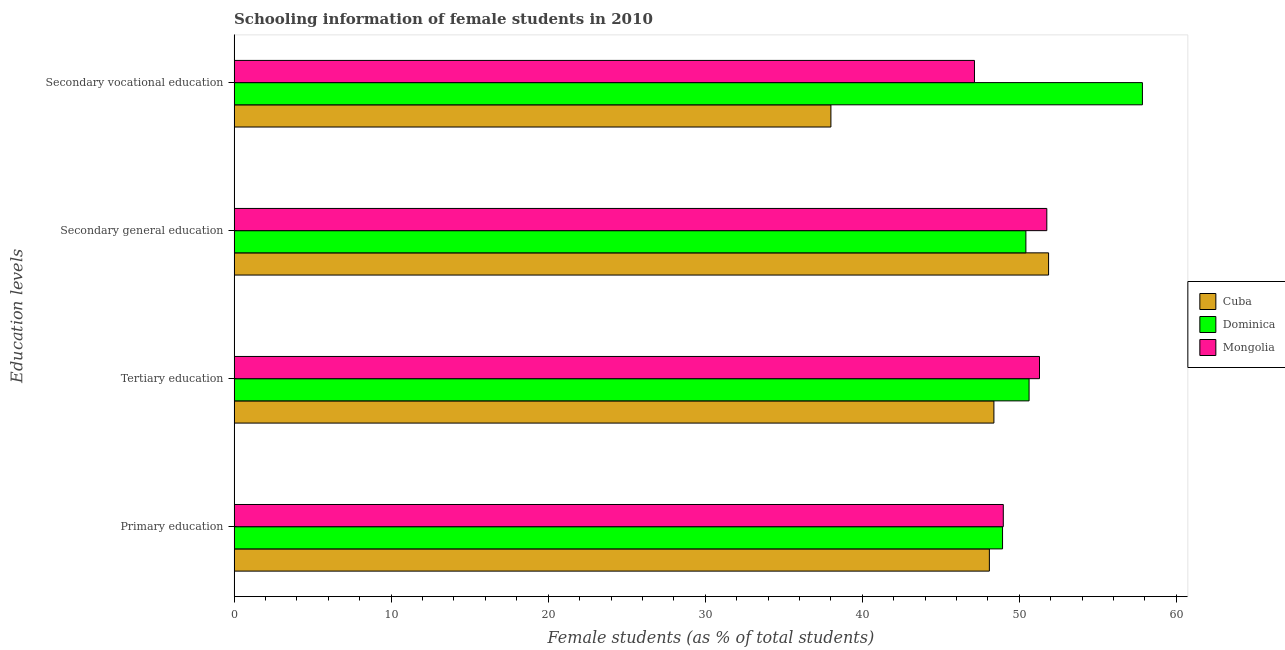Are the number of bars per tick equal to the number of legend labels?
Offer a very short reply. Yes. Are the number of bars on each tick of the Y-axis equal?
Make the answer very short. Yes. How many bars are there on the 4th tick from the bottom?
Offer a very short reply. 3. What is the label of the 3rd group of bars from the top?
Provide a succinct answer. Tertiary education. What is the percentage of female students in secondary vocational education in Mongolia?
Offer a terse response. 47.14. Across all countries, what is the maximum percentage of female students in secondary education?
Keep it short and to the point. 51.86. Across all countries, what is the minimum percentage of female students in secondary education?
Your answer should be compact. 50.42. In which country was the percentage of female students in tertiary education maximum?
Ensure brevity in your answer.  Mongolia. In which country was the percentage of female students in secondary vocational education minimum?
Provide a short and direct response. Cuba. What is the total percentage of female students in secondary vocational education in the graph?
Your answer should be compact. 142.98. What is the difference between the percentage of female students in secondary vocational education in Mongolia and that in Cuba?
Your response must be concise. 9.14. What is the difference between the percentage of female students in secondary vocational education in Mongolia and the percentage of female students in tertiary education in Cuba?
Make the answer very short. -1.24. What is the average percentage of female students in secondary education per country?
Provide a short and direct response. 51.34. What is the difference between the percentage of female students in secondary education and percentage of female students in secondary vocational education in Mongolia?
Make the answer very short. 4.61. What is the ratio of the percentage of female students in primary education in Dominica to that in Cuba?
Your answer should be compact. 1.02. What is the difference between the highest and the second highest percentage of female students in primary education?
Your answer should be very brief. 0.05. What is the difference between the highest and the lowest percentage of female students in secondary vocational education?
Offer a terse response. 19.84. In how many countries, is the percentage of female students in primary education greater than the average percentage of female students in primary education taken over all countries?
Keep it short and to the point. 2. Is it the case that in every country, the sum of the percentage of female students in tertiary education and percentage of female students in primary education is greater than the sum of percentage of female students in secondary vocational education and percentage of female students in secondary education?
Provide a succinct answer. No. What does the 1st bar from the top in Secondary general education represents?
Provide a succinct answer. Mongolia. What does the 2nd bar from the bottom in Secondary general education represents?
Your answer should be compact. Dominica. How many bars are there?
Provide a succinct answer. 12. Are all the bars in the graph horizontal?
Ensure brevity in your answer.  Yes. How many countries are there in the graph?
Make the answer very short. 3. Does the graph contain grids?
Your answer should be compact. No. Where does the legend appear in the graph?
Ensure brevity in your answer.  Center right. How are the legend labels stacked?
Make the answer very short. Vertical. What is the title of the graph?
Your answer should be compact. Schooling information of female students in 2010. What is the label or title of the X-axis?
Make the answer very short. Female students (as % of total students). What is the label or title of the Y-axis?
Keep it short and to the point. Education levels. What is the Female students (as % of total students) in Cuba in Primary education?
Provide a succinct answer. 48.09. What is the Female students (as % of total students) of Dominica in Primary education?
Provide a short and direct response. 48.93. What is the Female students (as % of total students) of Mongolia in Primary education?
Provide a short and direct response. 48.98. What is the Female students (as % of total students) in Cuba in Tertiary education?
Offer a very short reply. 48.38. What is the Female students (as % of total students) of Dominica in Tertiary education?
Make the answer very short. 50.62. What is the Female students (as % of total students) of Mongolia in Tertiary education?
Ensure brevity in your answer.  51.28. What is the Female students (as % of total students) of Cuba in Secondary general education?
Your response must be concise. 51.86. What is the Female students (as % of total students) of Dominica in Secondary general education?
Offer a very short reply. 50.42. What is the Female students (as % of total students) in Mongolia in Secondary general education?
Your answer should be compact. 51.75. What is the Female students (as % of total students) of Cuba in Secondary vocational education?
Keep it short and to the point. 38. What is the Female students (as % of total students) in Dominica in Secondary vocational education?
Your answer should be very brief. 57.84. What is the Female students (as % of total students) of Mongolia in Secondary vocational education?
Ensure brevity in your answer.  47.14. Across all Education levels, what is the maximum Female students (as % of total students) in Cuba?
Your answer should be very brief. 51.86. Across all Education levels, what is the maximum Female students (as % of total students) of Dominica?
Offer a very short reply. 57.84. Across all Education levels, what is the maximum Female students (as % of total students) in Mongolia?
Give a very brief answer. 51.75. Across all Education levels, what is the minimum Female students (as % of total students) in Cuba?
Make the answer very short. 38. Across all Education levels, what is the minimum Female students (as % of total students) of Dominica?
Make the answer very short. 48.93. Across all Education levels, what is the minimum Female students (as % of total students) of Mongolia?
Offer a very short reply. 47.14. What is the total Female students (as % of total students) in Cuba in the graph?
Your response must be concise. 186.34. What is the total Female students (as % of total students) in Dominica in the graph?
Make the answer very short. 207.81. What is the total Female students (as % of total students) of Mongolia in the graph?
Provide a short and direct response. 199.16. What is the difference between the Female students (as % of total students) of Cuba in Primary education and that in Tertiary education?
Keep it short and to the point. -0.29. What is the difference between the Female students (as % of total students) in Dominica in Primary education and that in Tertiary education?
Keep it short and to the point. -1.69. What is the difference between the Female students (as % of total students) in Mongolia in Primary education and that in Tertiary education?
Your response must be concise. -2.3. What is the difference between the Female students (as % of total students) of Cuba in Primary education and that in Secondary general education?
Your answer should be very brief. -3.77. What is the difference between the Female students (as % of total students) in Dominica in Primary education and that in Secondary general education?
Ensure brevity in your answer.  -1.49. What is the difference between the Female students (as % of total students) of Mongolia in Primary education and that in Secondary general education?
Your answer should be compact. -2.77. What is the difference between the Female students (as % of total students) in Cuba in Primary education and that in Secondary vocational education?
Ensure brevity in your answer.  10.09. What is the difference between the Female students (as % of total students) in Dominica in Primary education and that in Secondary vocational education?
Offer a very short reply. -8.91. What is the difference between the Female students (as % of total students) in Mongolia in Primary education and that in Secondary vocational education?
Offer a very short reply. 1.84. What is the difference between the Female students (as % of total students) in Cuba in Tertiary education and that in Secondary general education?
Provide a short and direct response. -3.48. What is the difference between the Female students (as % of total students) of Dominica in Tertiary education and that in Secondary general education?
Your response must be concise. 0.2. What is the difference between the Female students (as % of total students) of Mongolia in Tertiary education and that in Secondary general education?
Offer a terse response. -0.47. What is the difference between the Female students (as % of total students) of Cuba in Tertiary education and that in Secondary vocational education?
Provide a succinct answer. 10.38. What is the difference between the Female students (as % of total students) in Dominica in Tertiary education and that in Secondary vocational education?
Offer a very short reply. -7.22. What is the difference between the Female students (as % of total students) in Mongolia in Tertiary education and that in Secondary vocational education?
Offer a terse response. 4.14. What is the difference between the Female students (as % of total students) of Cuba in Secondary general education and that in Secondary vocational education?
Provide a short and direct response. 13.86. What is the difference between the Female students (as % of total students) in Dominica in Secondary general education and that in Secondary vocational education?
Give a very brief answer. -7.42. What is the difference between the Female students (as % of total students) of Mongolia in Secondary general education and that in Secondary vocational education?
Your response must be concise. 4.61. What is the difference between the Female students (as % of total students) of Cuba in Primary education and the Female students (as % of total students) of Dominica in Tertiary education?
Provide a short and direct response. -2.53. What is the difference between the Female students (as % of total students) of Cuba in Primary education and the Female students (as % of total students) of Mongolia in Tertiary education?
Your answer should be compact. -3.19. What is the difference between the Female students (as % of total students) in Dominica in Primary education and the Female students (as % of total students) in Mongolia in Tertiary education?
Provide a short and direct response. -2.35. What is the difference between the Female students (as % of total students) in Cuba in Primary education and the Female students (as % of total students) in Dominica in Secondary general education?
Provide a short and direct response. -2.33. What is the difference between the Female students (as % of total students) of Cuba in Primary education and the Female students (as % of total students) of Mongolia in Secondary general education?
Offer a very short reply. -3.66. What is the difference between the Female students (as % of total students) in Dominica in Primary education and the Female students (as % of total students) in Mongolia in Secondary general education?
Keep it short and to the point. -2.82. What is the difference between the Female students (as % of total students) in Cuba in Primary education and the Female students (as % of total students) in Dominica in Secondary vocational education?
Your answer should be very brief. -9.75. What is the difference between the Female students (as % of total students) of Cuba in Primary education and the Female students (as % of total students) of Mongolia in Secondary vocational education?
Offer a very short reply. 0.95. What is the difference between the Female students (as % of total students) in Dominica in Primary education and the Female students (as % of total students) in Mongolia in Secondary vocational education?
Keep it short and to the point. 1.79. What is the difference between the Female students (as % of total students) in Cuba in Tertiary education and the Female students (as % of total students) in Dominica in Secondary general education?
Ensure brevity in your answer.  -2.04. What is the difference between the Female students (as % of total students) of Cuba in Tertiary education and the Female students (as % of total students) of Mongolia in Secondary general education?
Provide a succinct answer. -3.37. What is the difference between the Female students (as % of total students) in Dominica in Tertiary education and the Female students (as % of total students) in Mongolia in Secondary general education?
Your response must be concise. -1.13. What is the difference between the Female students (as % of total students) in Cuba in Tertiary education and the Female students (as % of total students) in Dominica in Secondary vocational education?
Your answer should be very brief. -9.46. What is the difference between the Female students (as % of total students) in Cuba in Tertiary education and the Female students (as % of total students) in Mongolia in Secondary vocational education?
Offer a terse response. 1.24. What is the difference between the Female students (as % of total students) of Dominica in Tertiary education and the Female students (as % of total students) of Mongolia in Secondary vocational education?
Keep it short and to the point. 3.48. What is the difference between the Female students (as % of total students) of Cuba in Secondary general education and the Female students (as % of total students) of Dominica in Secondary vocational education?
Provide a short and direct response. -5.98. What is the difference between the Female students (as % of total students) in Cuba in Secondary general education and the Female students (as % of total students) in Mongolia in Secondary vocational education?
Your response must be concise. 4.72. What is the difference between the Female students (as % of total students) of Dominica in Secondary general education and the Female students (as % of total students) of Mongolia in Secondary vocational education?
Keep it short and to the point. 3.27. What is the average Female students (as % of total students) of Cuba per Education levels?
Keep it short and to the point. 46.58. What is the average Female students (as % of total students) of Dominica per Education levels?
Offer a very short reply. 51.95. What is the average Female students (as % of total students) in Mongolia per Education levels?
Ensure brevity in your answer.  49.79. What is the difference between the Female students (as % of total students) in Cuba and Female students (as % of total students) in Dominica in Primary education?
Your response must be concise. -0.84. What is the difference between the Female students (as % of total students) in Cuba and Female students (as % of total students) in Mongolia in Primary education?
Provide a short and direct response. -0.89. What is the difference between the Female students (as % of total students) in Dominica and Female students (as % of total students) in Mongolia in Primary education?
Your response must be concise. -0.05. What is the difference between the Female students (as % of total students) of Cuba and Female students (as % of total students) of Dominica in Tertiary education?
Offer a terse response. -2.24. What is the difference between the Female students (as % of total students) of Cuba and Female students (as % of total students) of Mongolia in Tertiary education?
Give a very brief answer. -2.9. What is the difference between the Female students (as % of total students) in Dominica and Female students (as % of total students) in Mongolia in Tertiary education?
Offer a terse response. -0.66. What is the difference between the Female students (as % of total students) in Cuba and Female students (as % of total students) in Dominica in Secondary general education?
Offer a terse response. 1.44. What is the difference between the Female students (as % of total students) of Cuba and Female students (as % of total students) of Mongolia in Secondary general education?
Ensure brevity in your answer.  0.11. What is the difference between the Female students (as % of total students) of Dominica and Female students (as % of total students) of Mongolia in Secondary general education?
Give a very brief answer. -1.33. What is the difference between the Female students (as % of total students) of Cuba and Female students (as % of total students) of Dominica in Secondary vocational education?
Your response must be concise. -19.84. What is the difference between the Female students (as % of total students) of Cuba and Female students (as % of total students) of Mongolia in Secondary vocational education?
Your response must be concise. -9.14. What is the difference between the Female students (as % of total students) of Dominica and Female students (as % of total students) of Mongolia in Secondary vocational education?
Offer a very short reply. 10.69. What is the ratio of the Female students (as % of total students) of Dominica in Primary education to that in Tertiary education?
Make the answer very short. 0.97. What is the ratio of the Female students (as % of total students) in Mongolia in Primary education to that in Tertiary education?
Your response must be concise. 0.96. What is the ratio of the Female students (as % of total students) of Cuba in Primary education to that in Secondary general education?
Keep it short and to the point. 0.93. What is the ratio of the Female students (as % of total students) in Dominica in Primary education to that in Secondary general education?
Give a very brief answer. 0.97. What is the ratio of the Female students (as % of total students) of Mongolia in Primary education to that in Secondary general education?
Make the answer very short. 0.95. What is the ratio of the Female students (as % of total students) in Cuba in Primary education to that in Secondary vocational education?
Your answer should be compact. 1.27. What is the ratio of the Female students (as % of total students) in Dominica in Primary education to that in Secondary vocational education?
Make the answer very short. 0.85. What is the ratio of the Female students (as % of total students) of Mongolia in Primary education to that in Secondary vocational education?
Provide a succinct answer. 1.04. What is the ratio of the Female students (as % of total students) of Cuba in Tertiary education to that in Secondary general education?
Make the answer very short. 0.93. What is the ratio of the Female students (as % of total students) of Cuba in Tertiary education to that in Secondary vocational education?
Make the answer very short. 1.27. What is the ratio of the Female students (as % of total students) of Dominica in Tertiary education to that in Secondary vocational education?
Give a very brief answer. 0.88. What is the ratio of the Female students (as % of total students) of Mongolia in Tertiary education to that in Secondary vocational education?
Your answer should be very brief. 1.09. What is the ratio of the Female students (as % of total students) in Cuba in Secondary general education to that in Secondary vocational education?
Give a very brief answer. 1.36. What is the ratio of the Female students (as % of total students) of Dominica in Secondary general education to that in Secondary vocational education?
Offer a terse response. 0.87. What is the ratio of the Female students (as % of total students) of Mongolia in Secondary general education to that in Secondary vocational education?
Provide a succinct answer. 1.1. What is the difference between the highest and the second highest Female students (as % of total students) of Cuba?
Offer a very short reply. 3.48. What is the difference between the highest and the second highest Female students (as % of total students) in Dominica?
Your answer should be very brief. 7.22. What is the difference between the highest and the second highest Female students (as % of total students) of Mongolia?
Provide a succinct answer. 0.47. What is the difference between the highest and the lowest Female students (as % of total students) in Cuba?
Provide a succinct answer. 13.86. What is the difference between the highest and the lowest Female students (as % of total students) in Dominica?
Your response must be concise. 8.91. What is the difference between the highest and the lowest Female students (as % of total students) in Mongolia?
Your answer should be compact. 4.61. 